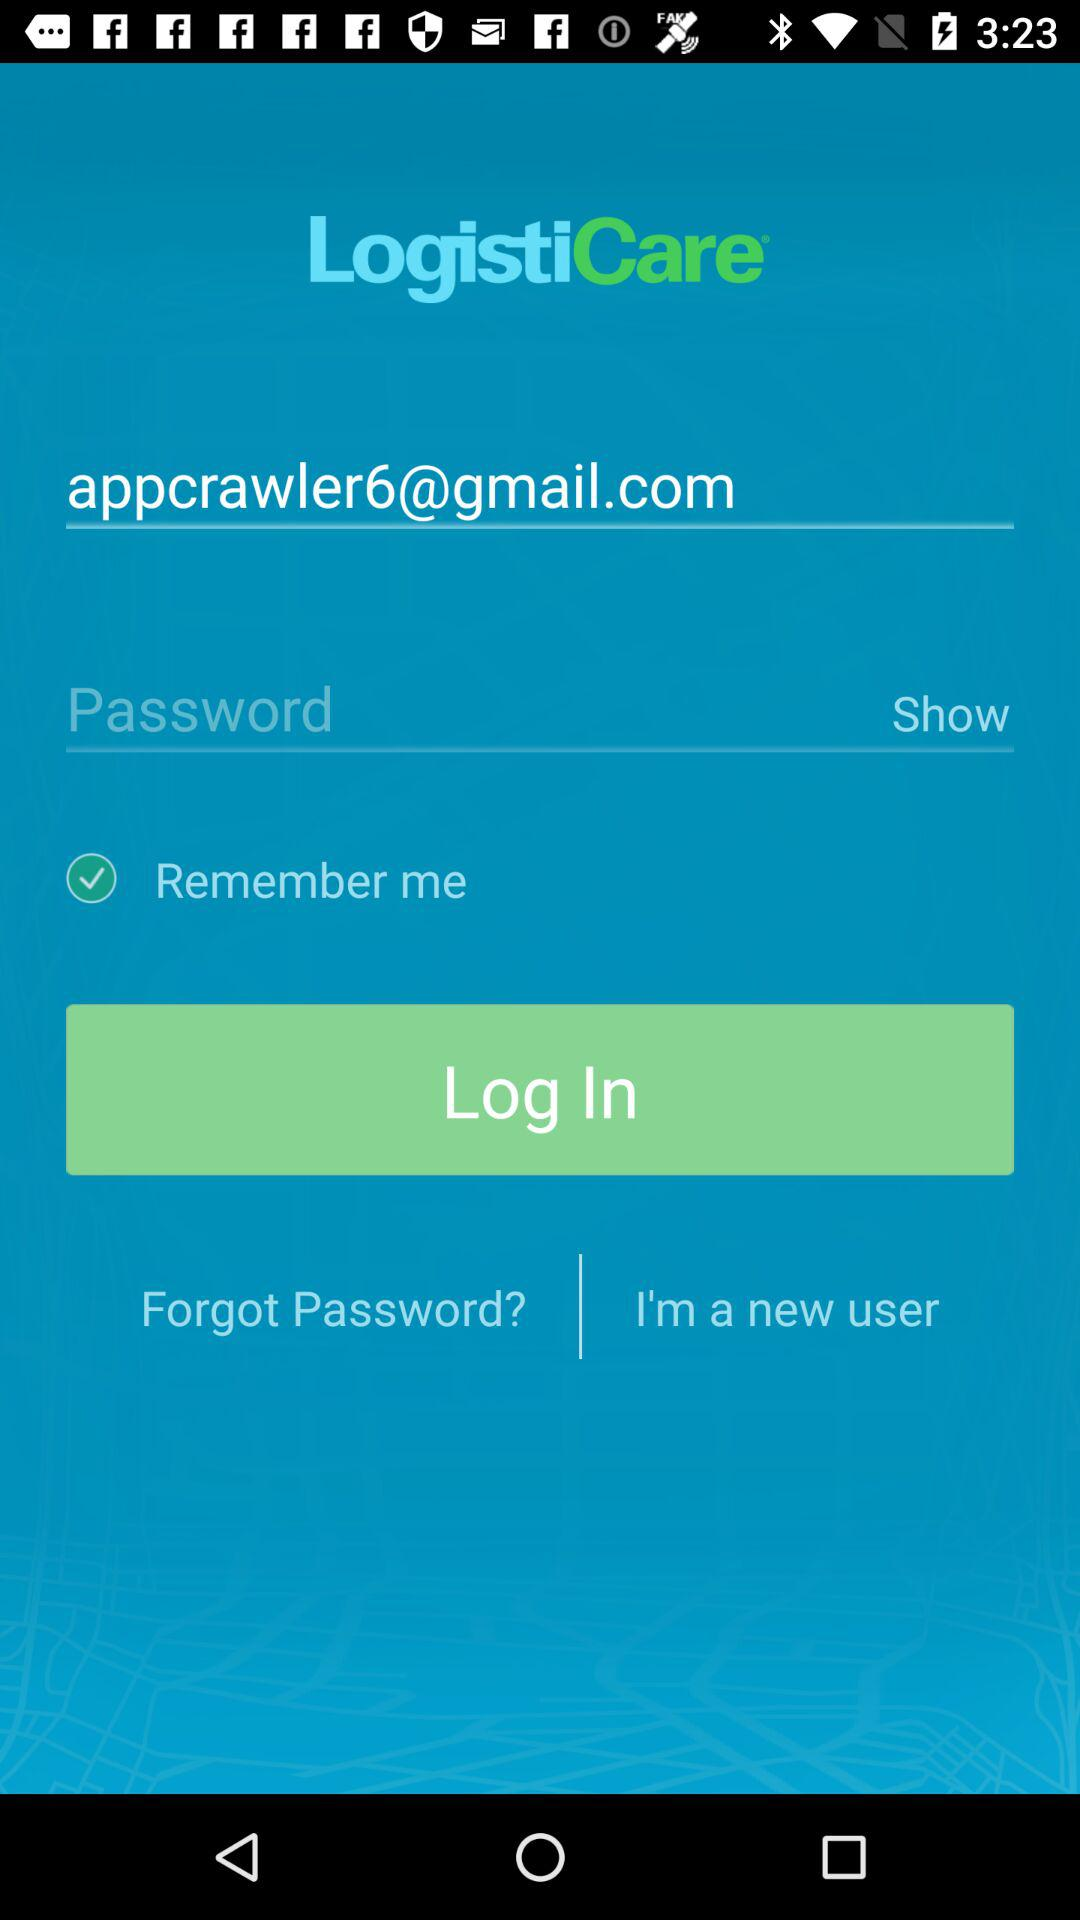What is the email address of the user? The email address of the user is appcrawler6@gmail.com. 